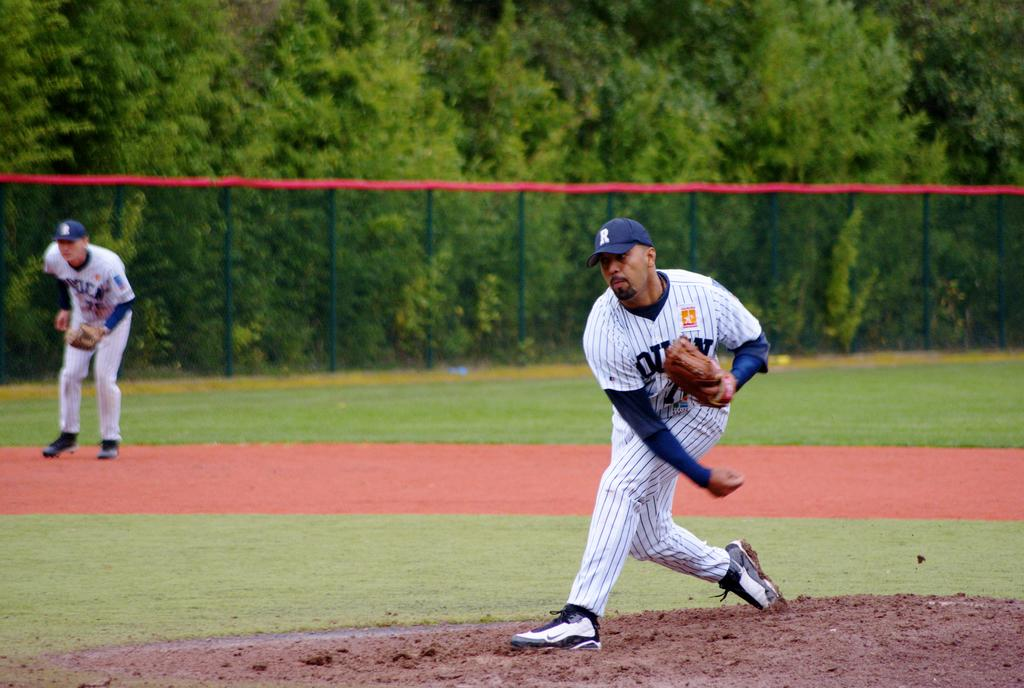<image>
Create a compact narrative representing the image presented. A baseball player with a R hat on throws a baseball while a teammate watches. 